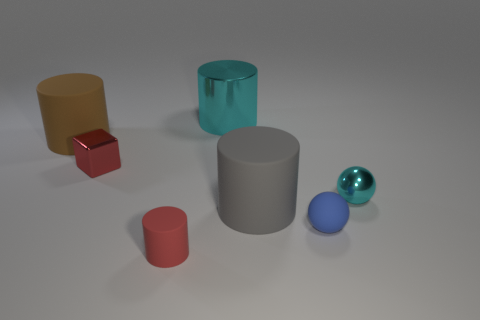What shape is the red rubber object?
Provide a succinct answer. Cylinder. Is the blue thing made of the same material as the large cyan object?
Give a very brief answer. No. Are there an equal number of small matte objects to the left of the rubber sphere and big gray things to the left of the small cylinder?
Give a very brief answer. No. There is a cylinder in front of the large cylinder that is in front of the cyan sphere; is there a metal sphere to the left of it?
Give a very brief answer. No. Do the block and the red matte object have the same size?
Give a very brief answer. Yes. What is the color of the large cylinder that is in front of the small red object that is behind the tiny blue matte ball that is right of the large cyan object?
Provide a short and direct response. Gray. What number of metallic cylinders have the same color as the metallic sphere?
Offer a terse response. 1. How many small things are either shiny things or cyan cylinders?
Your answer should be very brief. 2. Are there any big brown rubber objects of the same shape as the tiny cyan thing?
Give a very brief answer. No. Do the brown matte object and the big gray thing have the same shape?
Provide a succinct answer. Yes. 